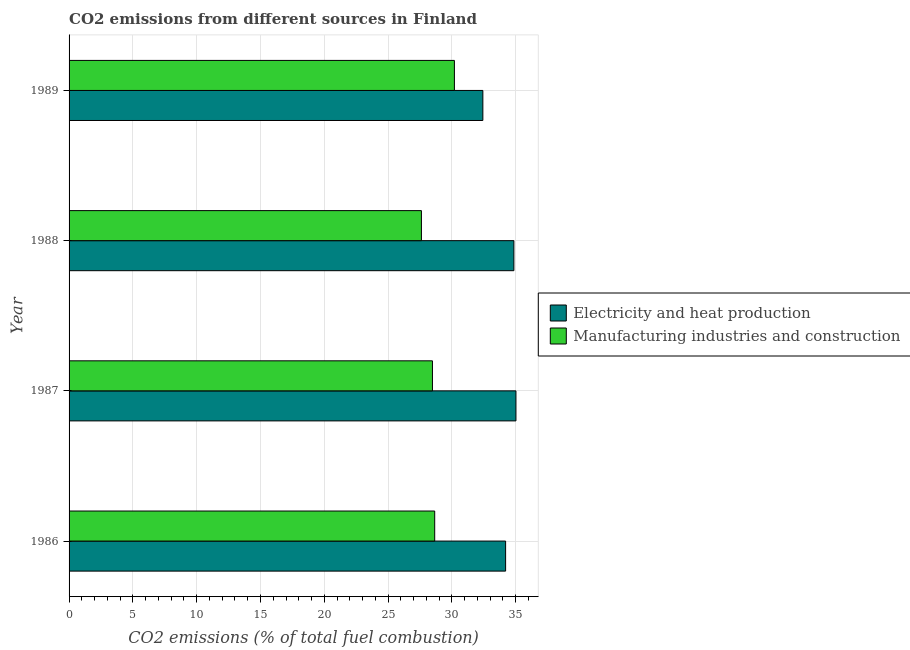Are the number of bars per tick equal to the number of legend labels?
Your answer should be compact. Yes. Are the number of bars on each tick of the Y-axis equal?
Provide a succinct answer. Yes. How many bars are there on the 1st tick from the bottom?
Provide a short and direct response. 2. In how many cases, is the number of bars for a given year not equal to the number of legend labels?
Your answer should be compact. 0. What is the co2 emissions due to electricity and heat production in 1986?
Offer a terse response. 34.21. Across all years, what is the maximum co2 emissions due to electricity and heat production?
Offer a very short reply. 35.02. Across all years, what is the minimum co2 emissions due to manufacturing industries?
Your answer should be very brief. 27.61. In which year was the co2 emissions due to manufacturing industries maximum?
Make the answer very short. 1989. In which year was the co2 emissions due to electricity and heat production minimum?
Your answer should be very brief. 1989. What is the total co2 emissions due to manufacturing industries in the graph?
Your response must be concise. 114.94. What is the difference between the co2 emissions due to electricity and heat production in 1987 and that in 1989?
Ensure brevity in your answer.  2.59. What is the difference between the co2 emissions due to electricity and heat production in 1989 and the co2 emissions due to manufacturing industries in 1987?
Make the answer very short. 3.95. What is the average co2 emissions due to electricity and heat production per year?
Make the answer very short. 34.13. In the year 1988, what is the difference between the co2 emissions due to manufacturing industries and co2 emissions due to electricity and heat production?
Provide a short and direct response. -7.25. In how many years, is the co2 emissions due to manufacturing industries greater than 4 %?
Provide a succinct answer. 4. What is the ratio of the co2 emissions due to manufacturing industries in 1987 to that in 1989?
Ensure brevity in your answer.  0.94. What is the difference between the highest and the second highest co2 emissions due to electricity and heat production?
Make the answer very short. 0.16. What is the difference between the highest and the lowest co2 emissions due to electricity and heat production?
Ensure brevity in your answer.  2.59. In how many years, is the co2 emissions due to manufacturing industries greater than the average co2 emissions due to manufacturing industries taken over all years?
Ensure brevity in your answer.  1. Is the sum of the co2 emissions due to electricity and heat production in 1986 and 1989 greater than the maximum co2 emissions due to manufacturing industries across all years?
Your response must be concise. Yes. What does the 1st bar from the top in 1988 represents?
Make the answer very short. Manufacturing industries and construction. What does the 2nd bar from the bottom in 1987 represents?
Your response must be concise. Manufacturing industries and construction. How many bars are there?
Your answer should be compact. 8. Are all the bars in the graph horizontal?
Your response must be concise. Yes. What is the difference between two consecutive major ticks on the X-axis?
Your answer should be compact. 5. Are the values on the major ticks of X-axis written in scientific E-notation?
Ensure brevity in your answer.  No. Does the graph contain any zero values?
Your response must be concise. No. How many legend labels are there?
Offer a terse response. 2. What is the title of the graph?
Ensure brevity in your answer.  CO2 emissions from different sources in Finland. What is the label or title of the X-axis?
Provide a succinct answer. CO2 emissions (% of total fuel combustion). What is the label or title of the Y-axis?
Make the answer very short. Year. What is the CO2 emissions (% of total fuel combustion) of Electricity and heat production in 1986?
Your answer should be very brief. 34.21. What is the CO2 emissions (% of total fuel combustion) of Manufacturing industries and construction in 1986?
Provide a succinct answer. 28.65. What is the CO2 emissions (% of total fuel combustion) of Electricity and heat production in 1987?
Keep it short and to the point. 35.02. What is the CO2 emissions (% of total fuel combustion) of Manufacturing industries and construction in 1987?
Your answer should be compact. 28.48. What is the CO2 emissions (% of total fuel combustion) in Electricity and heat production in 1988?
Keep it short and to the point. 34.86. What is the CO2 emissions (% of total fuel combustion) of Manufacturing industries and construction in 1988?
Provide a succinct answer. 27.61. What is the CO2 emissions (% of total fuel combustion) in Electricity and heat production in 1989?
Provide a succinct answer. 32.43. What is the CO2 emissions (% of total fuel combustion) in Manufacturing industries and construction in 1989?
Offer a terse response. 30.2. Across all years, what is the maximum CO2 emissions (% of total fuel combustion) in Electricity and heat production?
Your answer should be very brief. 35.02. Across all years, what is the maximum CO2 emissions (% of total fuel combustion) of Manufacturing industries and construction?
Offer a very short reply. 30.2. Across all years, what is the minimum CO2 emissions (% of total fuel combustion) of Electricity and heat production?
Provide a succinct answer. 32.43. Across all years, what is the minimum CO2 emissions (% of total fuel combustion) of Manufacturing industries and construction?
Make the answer very short. 27.61. What is the total CO2 emissions (% of total fuel combustion) in Electricity and heat production in the graph?
Provide a succinct answer. 136.51. What is the total CO2 emissions (% of total fuel combustion) of Manufacturing industries and construction in the graph?
Offer a very short reply. 114.94. What is the difference between the CO2 emissions (% of total fuel combustion) of Electricity and heat production in 1986 and that in 1987?
Provide a short and direct response. -0.81. What is the difference between the CO2 emissions (% of total fuel combustion) in Manufacturing industries and construction in 1986 and that in 1987?
Keep it short and to the point. 0.18. What is the difference between the CO2 emissions (% of total fuel combustion) in Electricity and heat production in 1986 and that in 1988?
Make the answer very short. -0.65. What is the difference between the CO2 emissions (% of total fuel combustion) of Manufacturing industries and construction in 1986 and that in 1988?
Keep it short and to the point. 1.04. What is the difference between the CO2 emissions (% of total fuel combustion) of Electricity and heat production in 1986 and that in 1989?
Your answer should be compact. 1.78. What is the difference between the CO2 emissions (% of total fuel combustion) of Manufacturing industries and construction in 1986 and that in 1989?
Give a very brief answer. -1.54. What is the difference between the CO2 emissions (% of total fuel combustion) in Electricity and heat production in 1987 and that in 1988?
Make the answer very short. 0.16. What is the difference between the CO2 emissions (% of total fuel combustion) in Manufacturing industries and construction in 1987 and that in 1988?
Offer a very short reply. 0.86. What is the difference between the CO2 emissions (% of total fuel combustion) in Electricity and heat production in 1987 and that in 1989?
Ensure brevity in your answer.  2.59. What is the difference between the CO2 emissions (% of total fuel combustion) in Manufacturing industries and construction in 1987 and that in 1989?
Your response must be concise. -1.72. What is the difference between the CO2 emissions (% of total fuel combustion) of Electricity and heat production in 1988 and that in 1989?
Offer a terse response. 2.43. What is the difference between the CO2 emissions (% of total fuel combustion) in Manufacturing industries and construction in 1988 and that in 1989?
Your answer should be very brief. -2.58. What is the difference between the CO2 emissions (% of total fuel combustion) in Electricity and heat production in 1986 and the CO2 emissions (% of total fuel combustion) in Manufacturing industries and construction in 1987?
Provide a short and direct response. 5.73. What is the difference between the CO2 emissions (% of total fuel combustion) in Electricity and heat production in 1986 and the CO2 emissions (% of total fuel combustion) in Manufacturing industries and construction in 1988?
Ensure brevity in your answer.  6.6. What is the difference between the CO2 emissions (% of total fuel combustion) of Electricity and heat production in 1986 and the CO2 emissions (% of total fuel combustion) of Manufacturing industries and construction in 1989?
Make the answer very short. 4.01. What is the difference between the CO2 emissions (% of total fuel combustion) of Electricity and heat production in 1987 and the CO2 emissions (% of total fuel combustion) of Manufacturing industries and construction in 1988?
Your answer should be compact. 7.41. What is the difference between the CO2 emissions (% of total fuel combustion) in Electricity and heat production in 1987 and the CO2 emissions (% of total fuel combustion) in Manufacturing industries and construction in 1989?
Provide a short and direct response. 4.82. What is the difference between the CO2 emissions (% of total fuel combustion) in Electricity and heat production in 1988 and the CO2 emissions (% of total fuel combustion) in Manufacturing industries and construction in 1989?
Make the answer very short. 4.66. What is the average CO2 emissions (% of total fuel combustion) of Electricity and heat production per year?
Provide a succinct answer. 34.13. What is the average CO2 emissions (% of total fuel combustion) in Manufacturing industries and construction per year?
Keep it short and to the point. 28.73. In the year 1986, what is the difference between the CO2 emissions (% of total fuel combustion) of Electricity and heat production and CO2 emissions (% of total fuel combustion) of Manufacturing industries and construction?
Provide a short and direct response. 5.56. In the year 1987, what is the difference between the CO2 emissions (% of total fuel combustion) in Electricity and heat production and CO2 emissions (% of total fuel combustion) in Manufacturing industries and construction?
Provide a short and direct response. 6.54. In the year 1988, what is the difference between the CO2 emissions (% of total fuel combustion) of Electricity and heat production and CO2 emissions (% of total fuel combustion) of Manufacturing industries and construction?
Your answer should be very brief. 7.25. In the year 1989, what is the difference between the CO2 emissions (% of total fuel combustion) in Electricity and heat production and CO2 emissions (% of total fuel combustion) in Manufacturing industries and construction?
Keep it short and to the point. 2.23. What is the ratio of the CO2 emissions (% of total fuel combustion) in Electricity and heat production in 1986 to that in 1987?
Provide a short and direct response. 0.98. What is the ratio of the CO2 emissions (% of total fuel combustion) in Electricity and heat production in 1986 to that in 1988?
Your answer should be very brief. 0.98. What is the ratio of the CO2 emissions (% of total fuel combustion) in Manufacturing industries and construction in 1986 to that in 1988?
Give a very brief answer. 1.04. What is the ratio of the CO2 emissions (% of total fuel combustion) of Electricity and heat production in 1986 to that in 1989?
Offer a terse response. 1.05. What is the ratio of the CO2 emissions (% of total fuel combustion) in Manufacturing industries and construction in 1986 to that in 1989?
Your response must be concise. 0.95. What is the ratio of the CO2 emissions (% of total fuel combustion) of Manufacturing industries and construction in 1987 to that in 1988?
Give a very brief answer. 1.03. What is the ratio of the CO2 emissions (% of total fuel combustion) in Electricity and heat production in 1987 to that in 1989?
Give a very brief answer. 1.08. What is the ratio of the CO2 emissions (% of total fuel combustion) in Manufacturing industries and construction in 1987 to that in 1989?
Offer a terse response. 0.94. What is the ratio of the CO2 emissions (% of total fuel combustion) of Electricity and heat production in 1988 to that in 1989?
Make the answer very short. 1.07. What is the ratio of the CO2 emissions (% of total fuel combustion) in Manufacturing industries and construction in 1988 to that in 1989?
Your response must be concise. 0.91. What is the difference between the highest and the second highest CO2 emissions (% of total fuel combustion) of Electricity and heat production?
Offer a terse response. 0.16. What is the difference between the highest and the second highest CO2 emissions (% of total fuel combustion) in Manufacturing industries and construction?
Keep it short and to the point. 1.54. What is the difference between the highest and the lowest CO2 emissions (% of total fuel combustion) of Electricity and heat production?
Provide a short and direct response. 2.59. What is the difference between the highest and the lowest CO2 emissions (% of total fuel combustion) of Manufacturing industries and construction?
Your response must be concise. 2.58. 